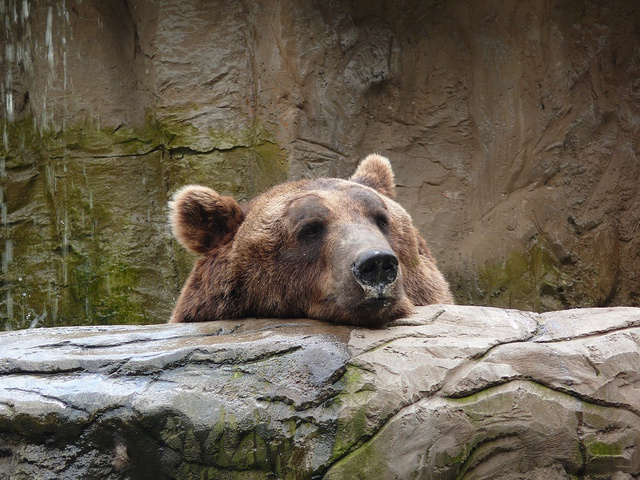Describe the objects in this image and their specific colors. I can see a bear in gray, black, and maroon tones in this image. 